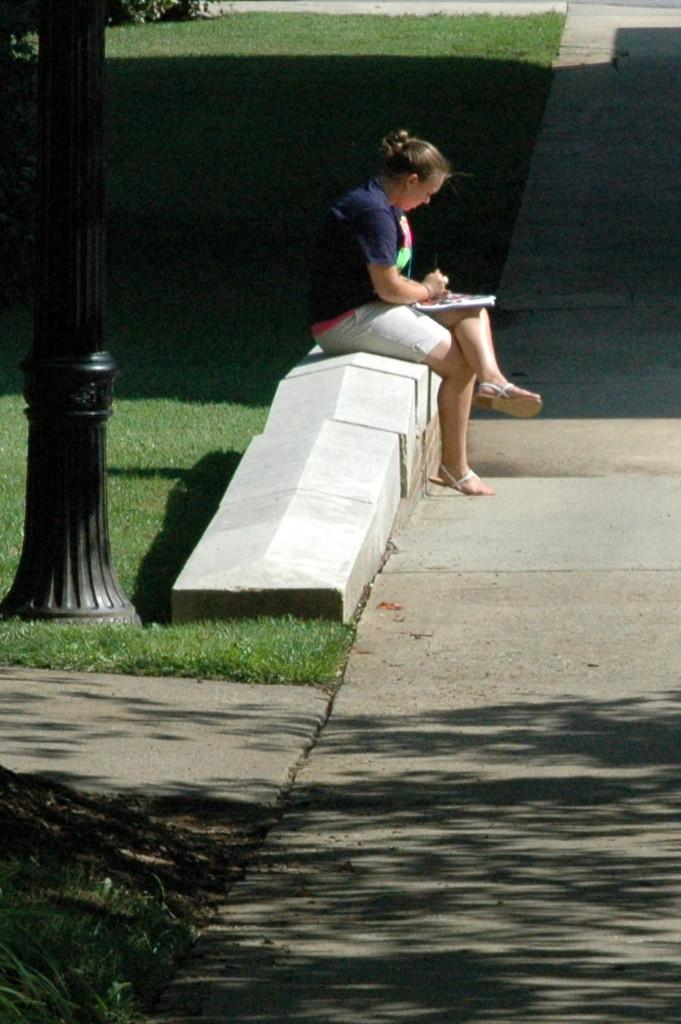What is the prominent object in the image? There is a black pole in the image. How many roads can be seen in the image? There are three roads in the image. What type of vegetation is visible in the image? There is grass visible in the image, and trees are present on the ground. Who is in the image, and what is she doing? There is a woman sitting in the image, and she is holding a book and reading it. What type of system is being used to reduce friction in the image? There is no mention of a system or friction in the image; it features a black pole, three roads, grass, trees, and a woman reading a book. 